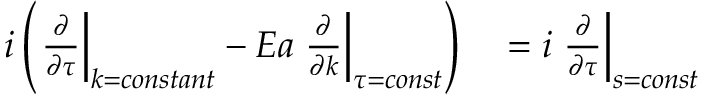<formula> <loc_0><loc_0><loc_500><loc_500>\begin{array} { r l } { i \left ( \frac { \partial } { \partial \tau } \right | _ { k = c o n s t a n t } - E a \frac { \partial } { \partial k } \right | _ { \tau = c o n s t } \right ) } & = i \frac { \partial } { \partial \tau } \right | _ { s = c o n s t } } \end{array}</formula> 